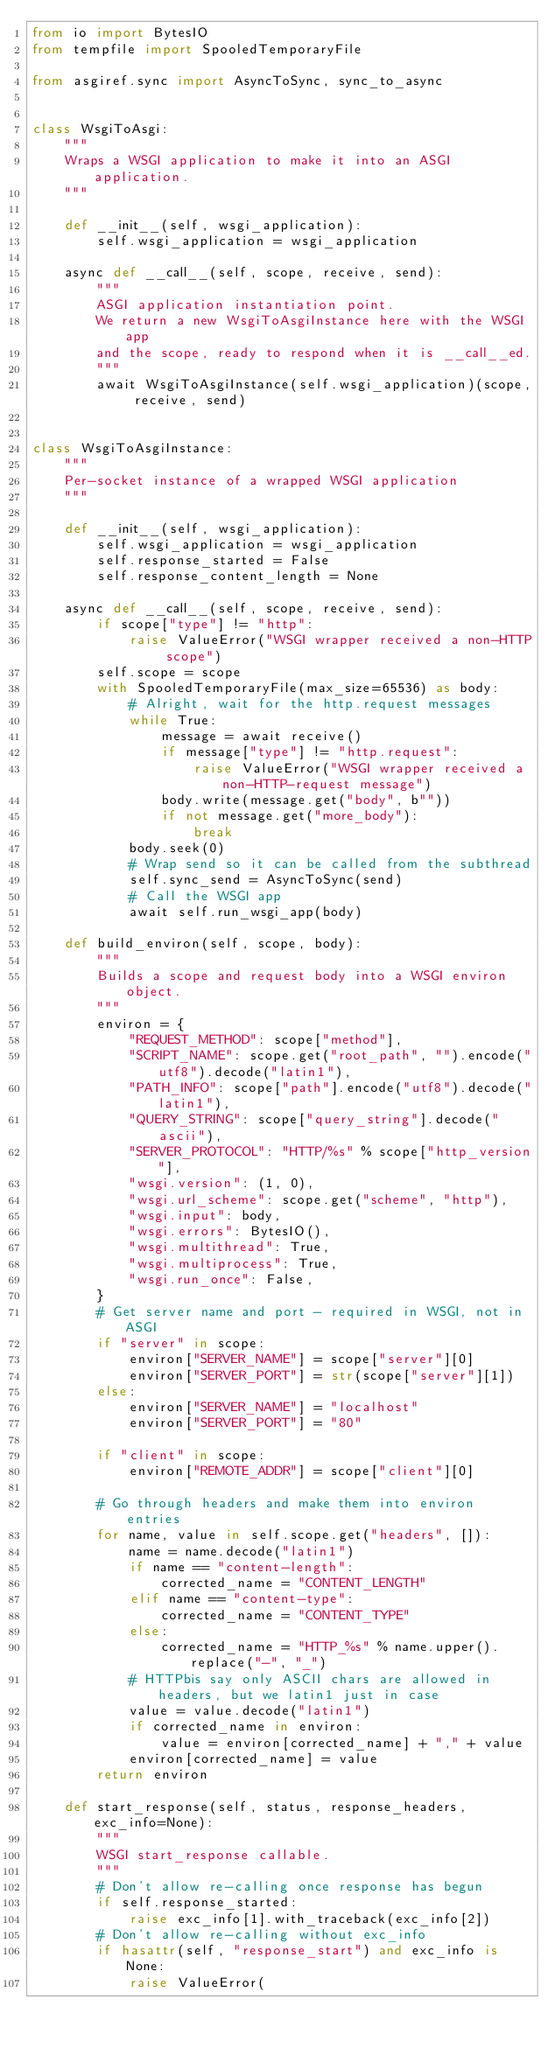<code> <loc_0><loc_0><loc_500><loc_500><_Python_>from io import BytesIO
from tempfile import SpooledTemporaryFile

from asgiref.sync import AsyncToSync, sync_to_async


class WsgiToAsgi:
    """
    Wraps a WSGI application to make it into an ASGI application.
    """

    def __init__(self, wsgi_application):
        self.wsgi_application = wsgi_application

    async def __call__(self, scope, receive, send):
        """
        ASGI application instantiation point.
        We return a new WsgiToAsgiInstance here with the WSGI app
        and the scope, ready to respond when it is __call__ed.
        """
        await WsgiToAsgiInstance(self.wsgi_application)(scope, receive, send)


class WsgiToAsgiInstance:
    """
    Per-socket instance of a wrapped WSGI application
    """

    def __init__(self, wsgi_application):
        self.wsgi_application = wsgi_application
        self.response_started = False
        self.response_content_length = None

    async def __call__(self, scope, receive, send):
        if scope["type"] != "http":
            raise ValueError("WSGI wrapper received a non-HTTP scope")
        self.scope = scope
        with SpooledTemporaryFile(max_size=65536) as body:
            # Alright, wait for the http.request messages
            while True:
                message = await receive()
                if message["type"] != "http.request":
                    raise ValueError("WSGI wrapper received a non-HTTP-request message")
                body.write(message.get("body", b""))
                if not message.get("more_body"):
                    break
            body.seek(0)
            # Wrap send so it can be called from the subthread
            self.sync_send = AsyncToSync(send)
            # Call the WSGI app
            await self.run_wsgi_app(body)

    def build_environ(self, scope, body):
        """
        Builds a scope and request body into a WSGI environ object.
        """
        environ = {
            "REQUEST_METHOD": scope["method"],
            "SCRIPT_NAME": scope.get("root_path", "").encode("utf8").decode("latin1"),
            "PATH_INFO": scope["path"].encode("utf8").decode("latin1"),
            "QUERY_STRING": scope["query_string"].decode("ascii"),
            "SERVER_PROTOCOL": "HTTP/%s" % scope["http_version"],
            "wsgi.version": (1, 0),
            "wsgi.url_scheme": scope.get("scheme", "http"),
            "wsgi.input": body,
            "wsgi.errors": BytesIO(),
            "wsgi.multithread": True,
            "wsgi.multiprocess": True,
            "wsgi.run_once": False,
        }
        # Get server name and port - required in WSGI, not in ASGI
        if "server" in scope:
            environ["SERVER_NAME"] = scope["server"][0]
            environ["SERVER_PORT"] = str(scope["server"][1])
        else:
            environ["SERVER_NAME"] = "localhost"
            environ["SERVER_PORT"] = "80"

        if "client" in scope:
            environ["REMOTE_ADDR"] = scope["client"][0]

        # Go through headers and make them into environ entries
        for name, value in self.scope.get("headers", []):
            name = name.decode("latin1")
            if name == "content-length":
                corrected_name = "CONTENT_LENGTH"
            elif name == "content-type":
                corrected_name = "CONTENT_TYPE"
            else:
                corrected_name = "HTTP_%s" % name.upper().replace("-", "_")
            # HTTPbis say only ASCII chars are allowed in headers, but we latin1 just in case
            value = value.decode("latin1")
            if corrected_name in environ:
                value = environ[corrected_name] + "," + value
            environ[corrected_name] = value
        return environ

    def start_response(self, status, response_headers, exc_info=None):
        """
        WSGI start_response callable.
        """
        # Don't allow re-calling once response has begun
        if self.response_started:
            raise exc_info[1].with_traceback(exc_info[2])
        # Don't allow re-calling without exc_info
        if hasattr(self, "response_start") and exc_info is None:
            raise ValueError(</code> 